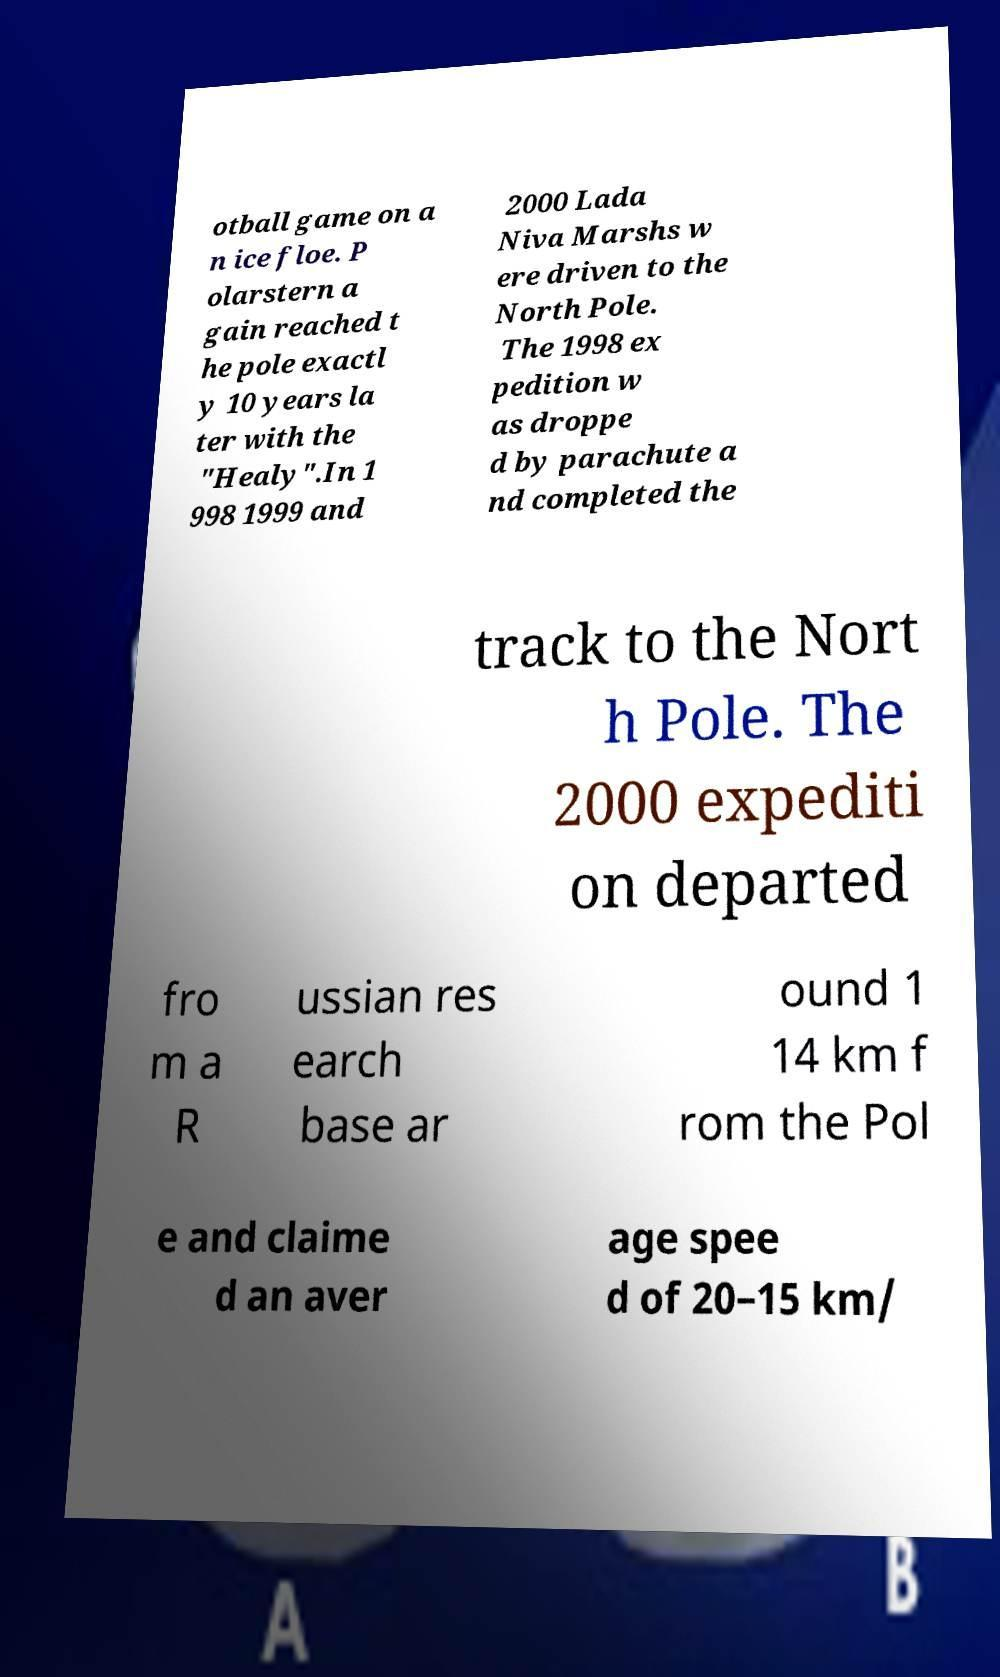Please read and relay the text visible in this image. What does it say? otball game on a n ice floe. P olarstern a gain reached t he pole exactl y 10 years la ter with the "Healy".In 1 998 1999 and 2000 Lada Niva Marshs w ere driven to the North Pole. The 1998 ex pedition w as droppe d by parachute a nd completed the track to the Nort h Pole. The 2000 expediti on departed fro m a R ussian res earch base ar ound 1 14 km f rom the Pol e and claime d an aver age spee d of 20–15 km/ 